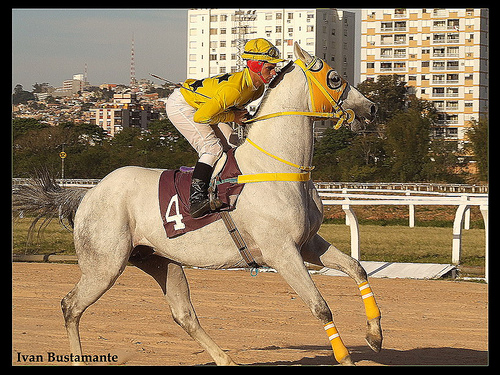<image>
Is the man above the horse? No. The man is not positioned above the horse. The vertical arrangement shows a different relationship. 